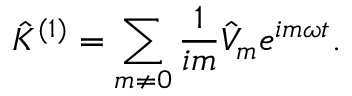<formula> <loc_0><loc_0><loc_500><loc_500>\hat { K } ^ { ( 1 ) } = \sum _ { m \neq 0 } \frac { 1 } { i m } \hat { V } _ { m } e ^ { i m \omega t } .</formula> 